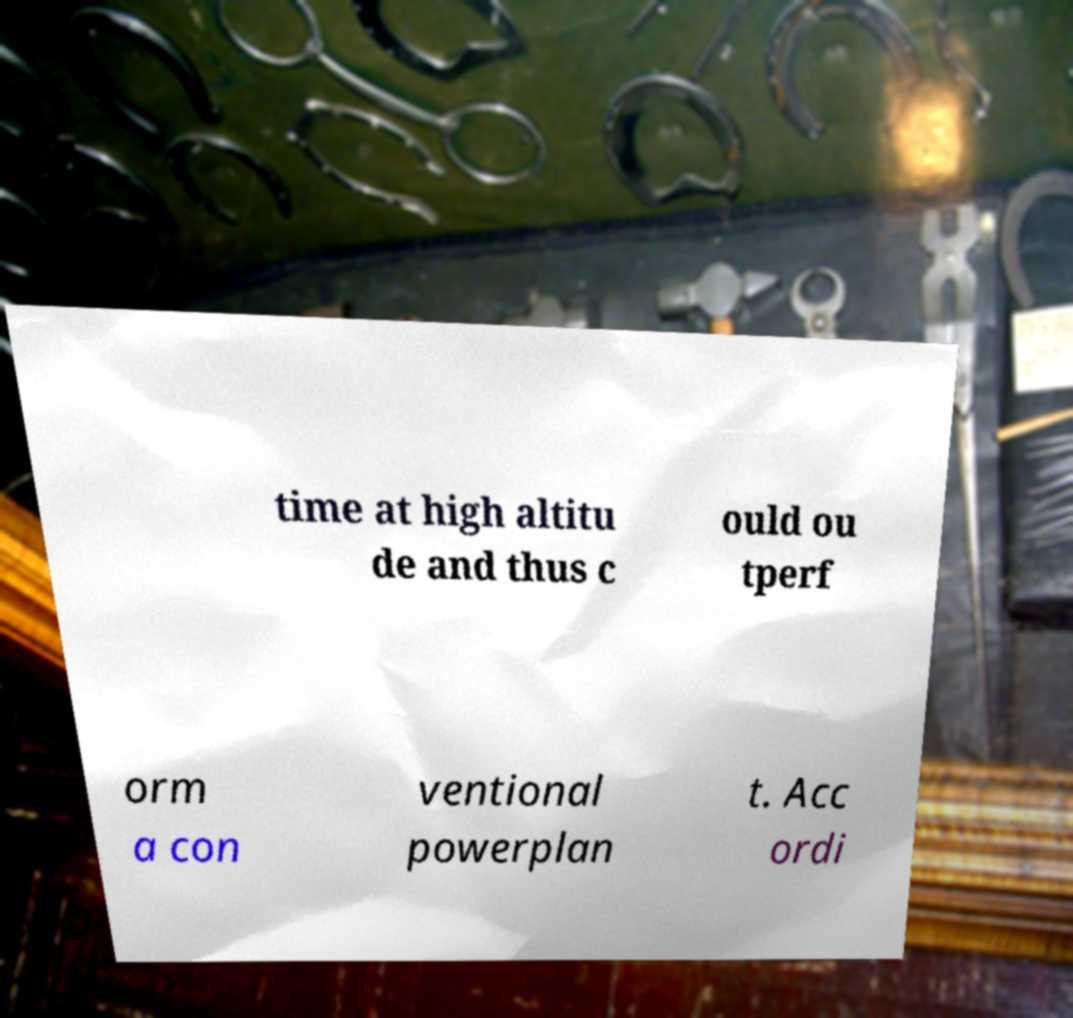Can you read and provide the text displayed in the image?This photo seems to have some interesting text. Can you extract and type it out for me? time at high altitu de and thus c ould ou tperf orm a con ventional powerplan t. Acc ordi 